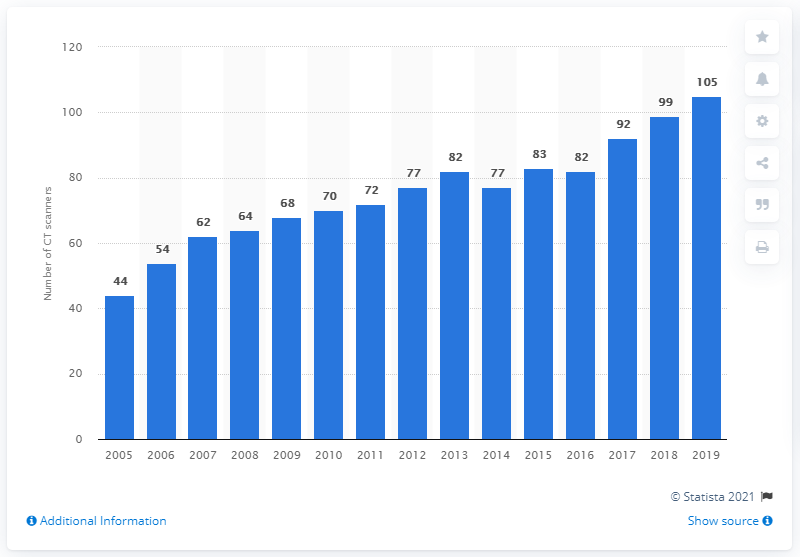Specify some key components in this picture. In 2019, there were 105 computed tomography (CT) scanners in Ireland. 